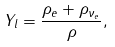<formula> <loc_0><loc_0><loc_500><loc_500>Y _ { l } = \frac { \rho _ { e } + \rho _ { \nu _ { e } } } { \rho } ,</formula> 